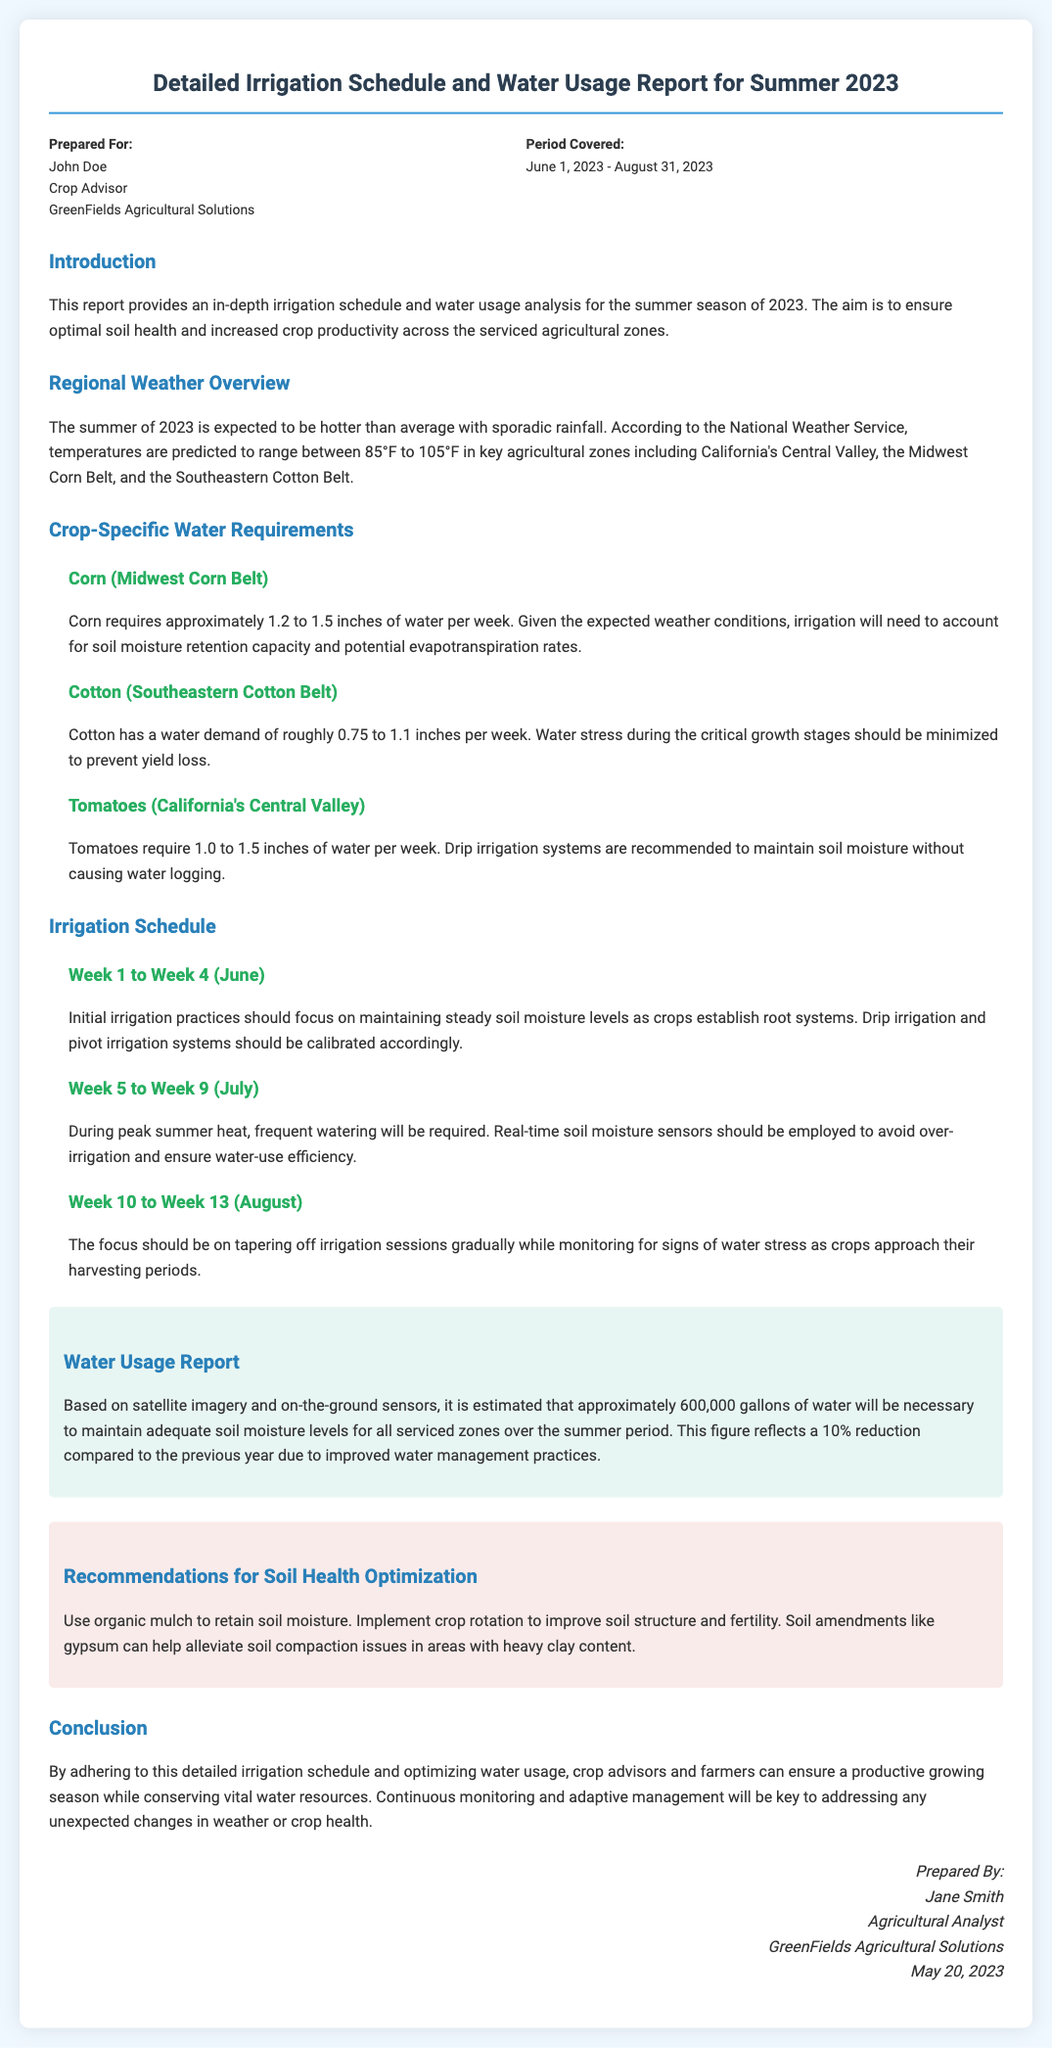What is the title of the report? The title is presented as the main heading of the document, which states the subject and time frame being addressed.
Answer: Detailed Irrigation Schedule and Water Usage Report for Summer 2023 Who prepared the report? The document lists the individual who prepared the report in the footer section, indicating their name and role.
Answer: Jane Smith What is the period covered by the report? The report specifies the duration it covers in the header section, indicating the start and end dates.
Answer: June 1, 2023 - August 31, 2023 What is the estimated total water usage? The document provides an estimated figure for total water usage based on the analysis presented in the water usage report section.
Answer: 600,000 gallons Which crop requires 1.2 to 1.5 inches of water per week? The report details the water requirements for different crops, specifying this particular range for one crop.
Answer: Corn What irrigation method is recommended for tomatoes? The document suggests a specific irrigation technique for tomatoes in the crop-specific water requirements section.
Answer: Drip irrigation During which weeks should frequent watering be required? The irrigation schedule outlines specific weeks where increased irrigation is necessary based on temperature conditions.
Answer: Week 5 to Week 9 (July) What is one recommendation for optimizing soil health? The recommendations section provides strategies for improving soil health, of which this is one.
Answer: Use organic mulch to retain soil moisture 